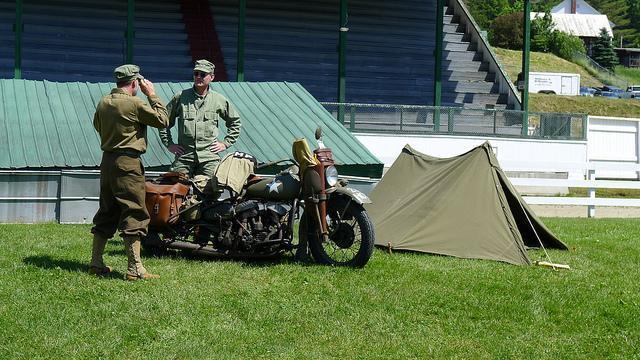Which one is the superior officer?
Choose the correct response, then elucidate: 'Answer: answer
Rationale: rationale.'
Options: Can't tell, in trailer, facing camera, back turned. Answer: facing camera.
Rationale: The man with his arms on his hips looks more assertive. 